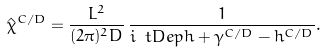Convert formula to latex. <formula><loc_0><loc_0><loc_500><loc_500>\hat { \chi } ^ { C / D } = \frac { L ^ { 2 } } { ( 2 \pi ) ^ { 2 } D } \, \frac { 1 } { i \ t D e p h + \gamma ^ { C / D } - h ^ { C / D } } .</formula> 